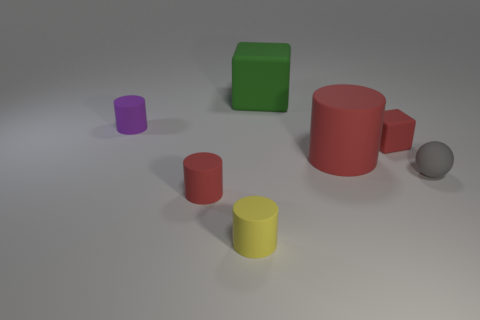Subtract all tiny cylinders. How many cylinders are left? 1 Add 1 big green cubes. How many objects exist? 8 Subtract all green cubes. How many cubes are left? 1 Subtract all blocks. How many objects are left? 5 Add 5 tiny yellow matte cylinders. How many tiny yellow matte cylinders exist? 6 Subtract 0 blue spheres. How many objects are left? 7 Subtract 4 cylinders. How many cylinders are left? 0 Subtract all cyan blocks. Subtract all brown cylinders. How many blocks are left? 2 Subtract all red cubes. How many red cylinders are left? 2 Subtract all matte things. Subtract all large purple objects. How many objects are left? 0 